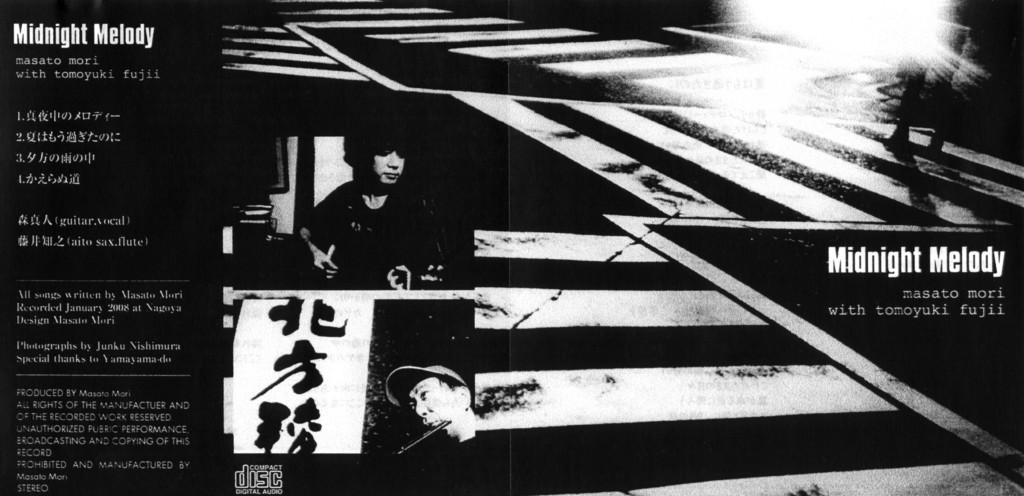Provide a one-sentence caption for the provided image. A Japanese advertisement for a rockband called Midnight Melody. 